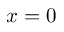<formula> <loc_0><loc_0><loc_500><loc_500>x = 0</formula> 